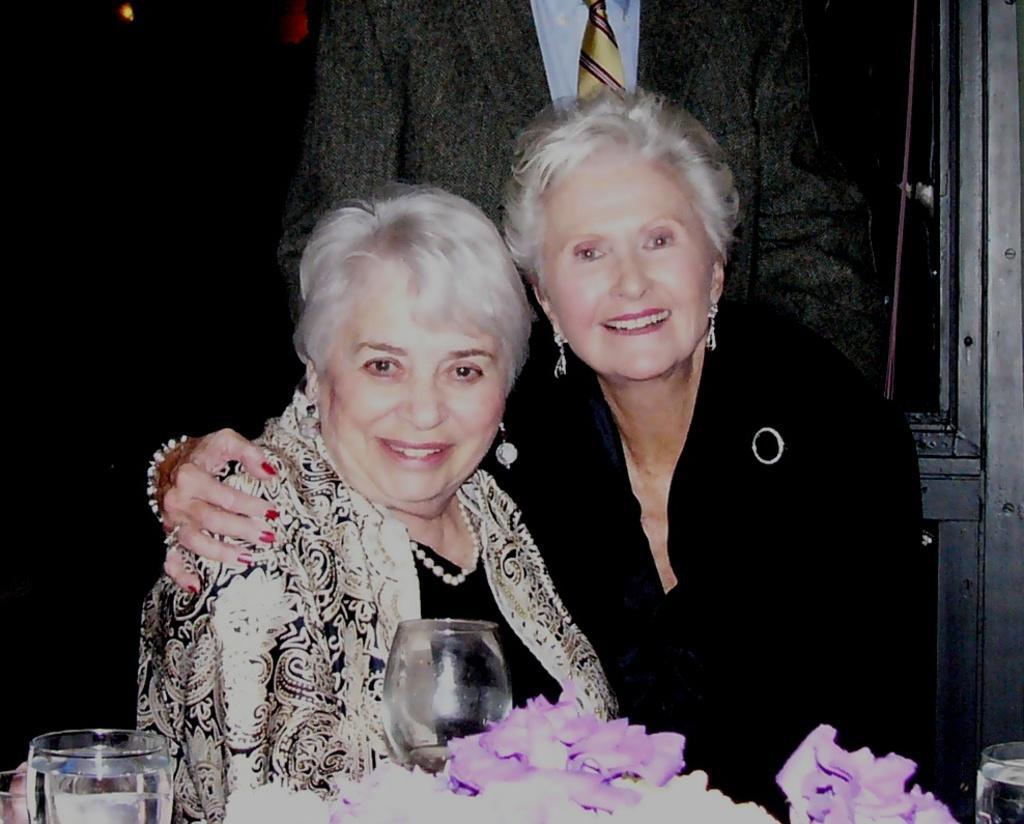Could you give a brief overview of what you see in this image? In the picture we can see two women sitting in the chair and holding each other and smiling and near to them, we can see a table on it, we can see two glasses and flowers which are violet in color and some are white in color and in the background we can see a man standing and wearing a blazer with tie and shirt. 